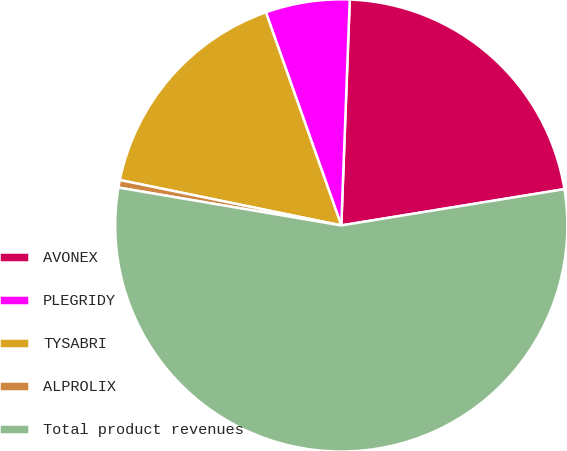Convert chart. <chart><loc_0><loc_0><loc_500><loc_500><pie_chart><fcel>AVONEX<fcel>PLEGRIDY<fcel>TYSABRI<fcel>ALPROLIX<fcel>Total product revenues<nl><fcel>21.84%<fcel>6.01%<fcel>16.37%<fcel>0.54%<fcel>55.25%<nl></chart> 